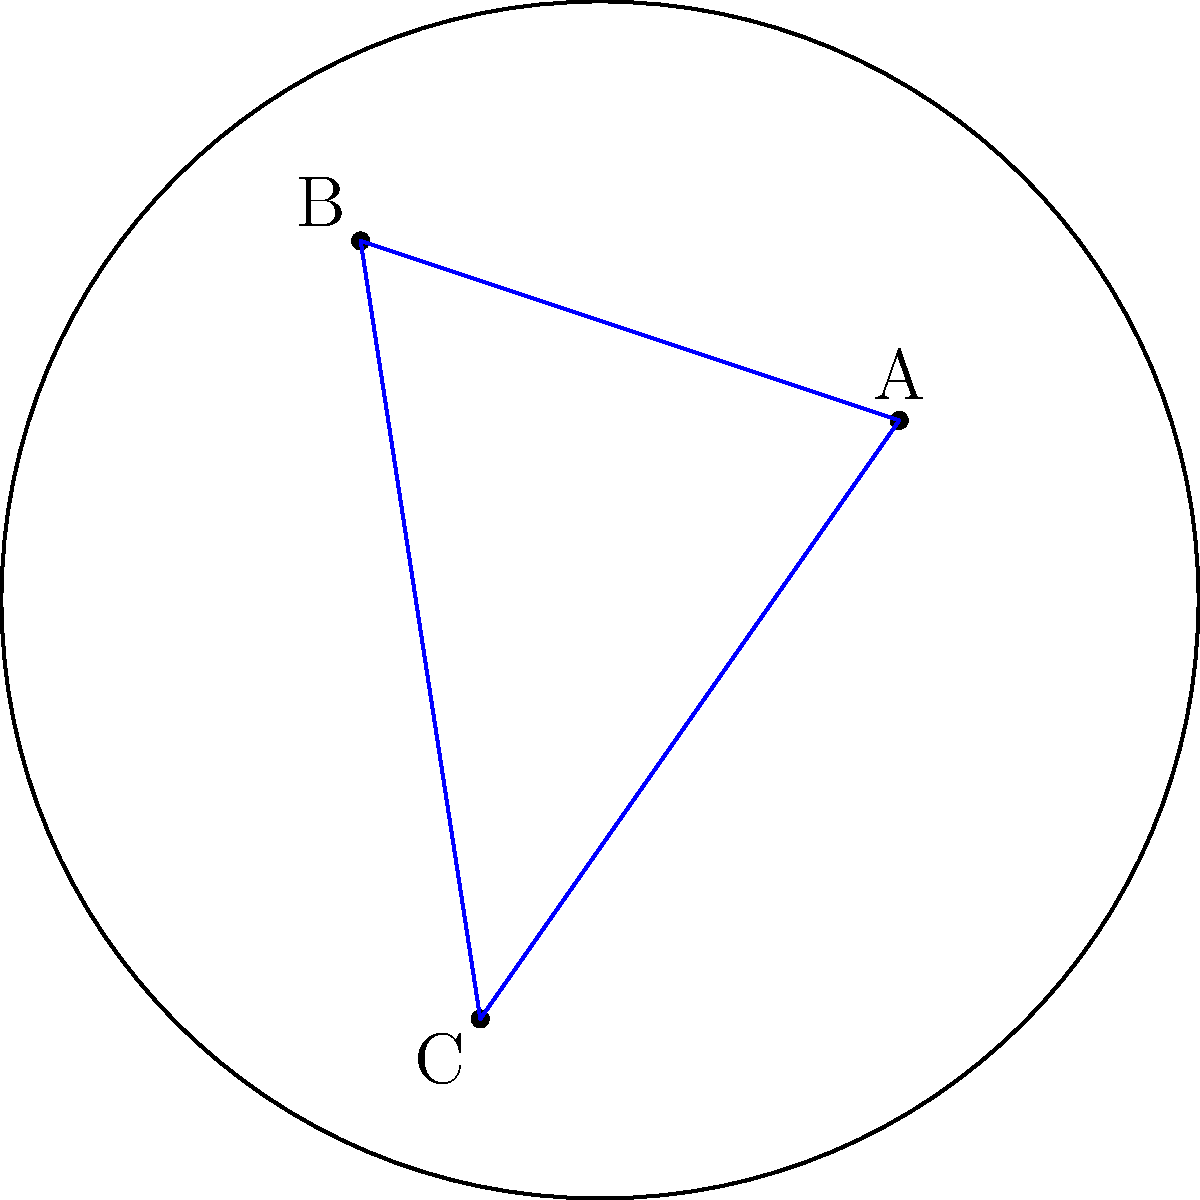On a Poincaré disk model of a race circuit, three checkpoints A, B, and C are positioned as shown. If the hyperbolic distance between A and B is 1.5 units, and between B and C is 2.0 units, what is the approximate hyperbolic distance between A and C? To solve this problem, we need to follow these steps:

1) In the Poincaré disk model, straight lines are represented by arcs of circles that intersect the boundary of the disk at right angles. The triangle ABC in the model represents a hyperbolic triangle.

2) In hyperbolic geometry, the triangle inequality still holds, but it's stricter than in Euclidean geometry. For any hyperbolic triangle with sides a, b, and c:

   $$ a < b + c $$

3) We're given that:
   AB = 1.5 units
   BC = 2.0 units

4) The distance AC must be less than the sum of AB and BC:

   $$ AC < AB + BC = 1.5 + 2.0 = 3.5 $$

5) However, in hyperbolic geometry, the difference between the sum of two sides and the third side is typically larger than in Euclidean geometry. 

6) A reasonable estimate would be that AC is about 2/3 to 3/4 of the sum of AB and BC.

7) Therefore, we can estimate:

   $$ AC \approx 0.7 * (AB + BC) = 0.7 * (1.5 + 2.0) = 0.7 * 3.5 = 2.45 $$

8) Rounding to a reasonable precision for this estimate, we get approximately 2.5 units.
Answer: Approximately 2.5 units 